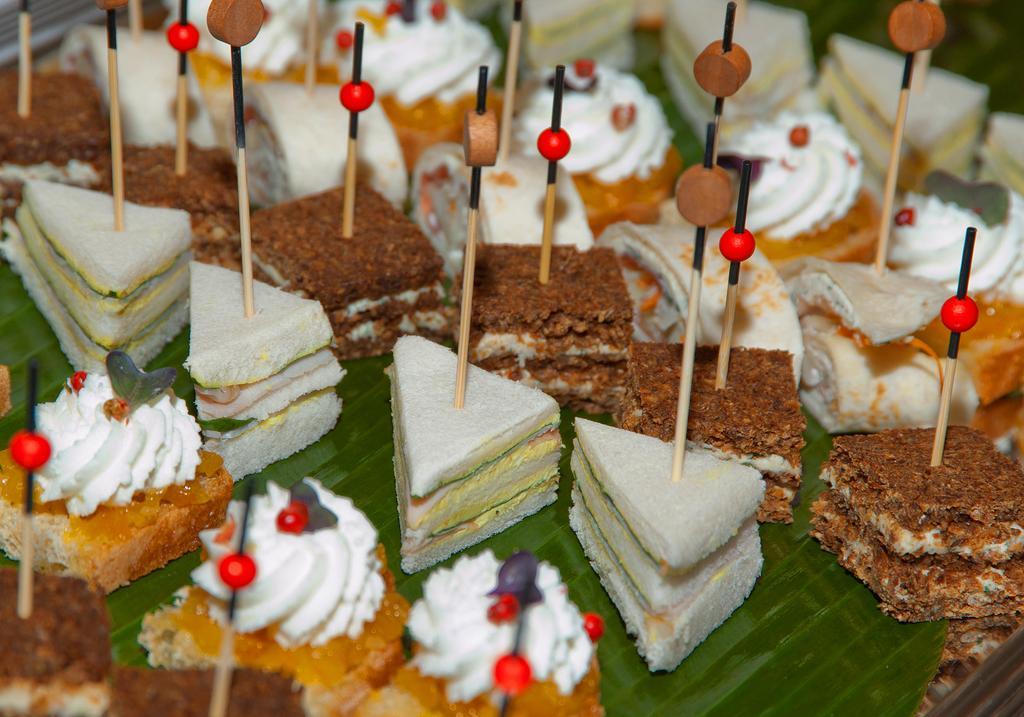Can you describe this image briefly? In this image I see different types of food and I see stocks on most of the food items. 